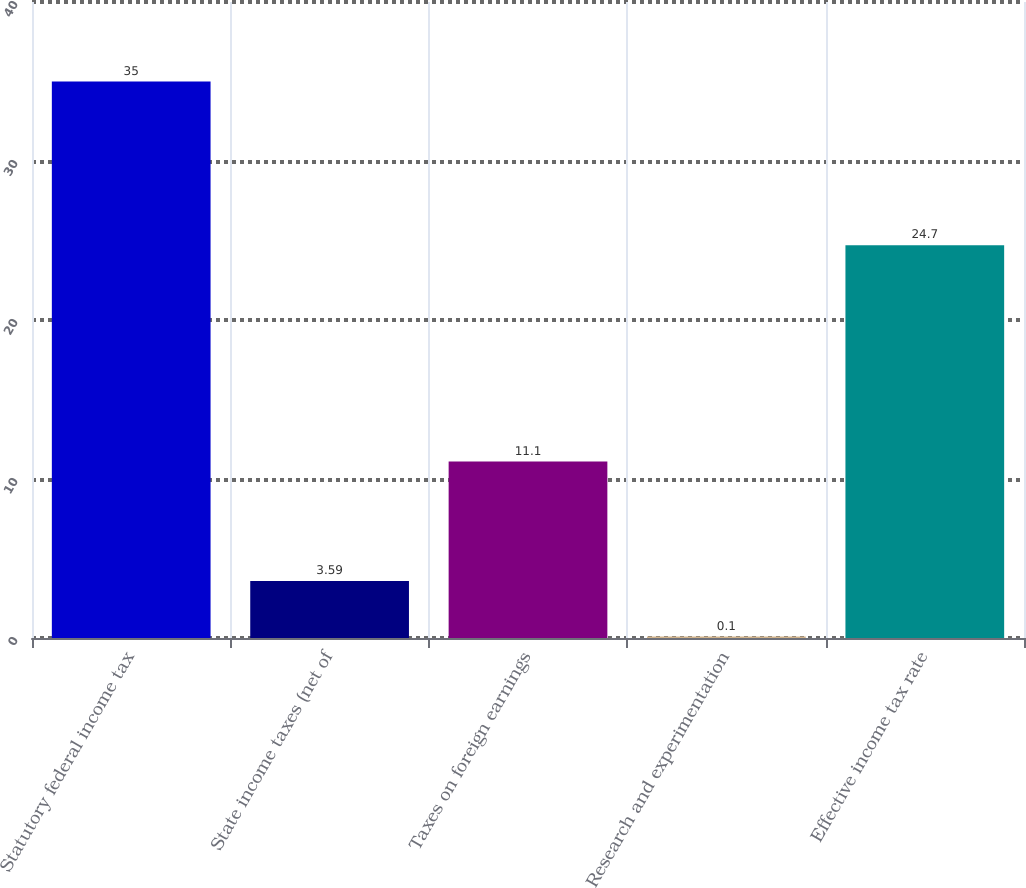Convert chart to OTSL. <chart><loc_0><loc_0><loc_500><loc_500><bar_chart><fcel>Statutory federal income tax<fcel>State income taxes (net of<fcel>Taxes on foreign earnings<fcel>Research and experimentation<fcel>Effective income tax rate<nl><fcel>35<fcel>3.59<fcel>11.1<fcel>0.1<fcel>24.7<nl></chart> 